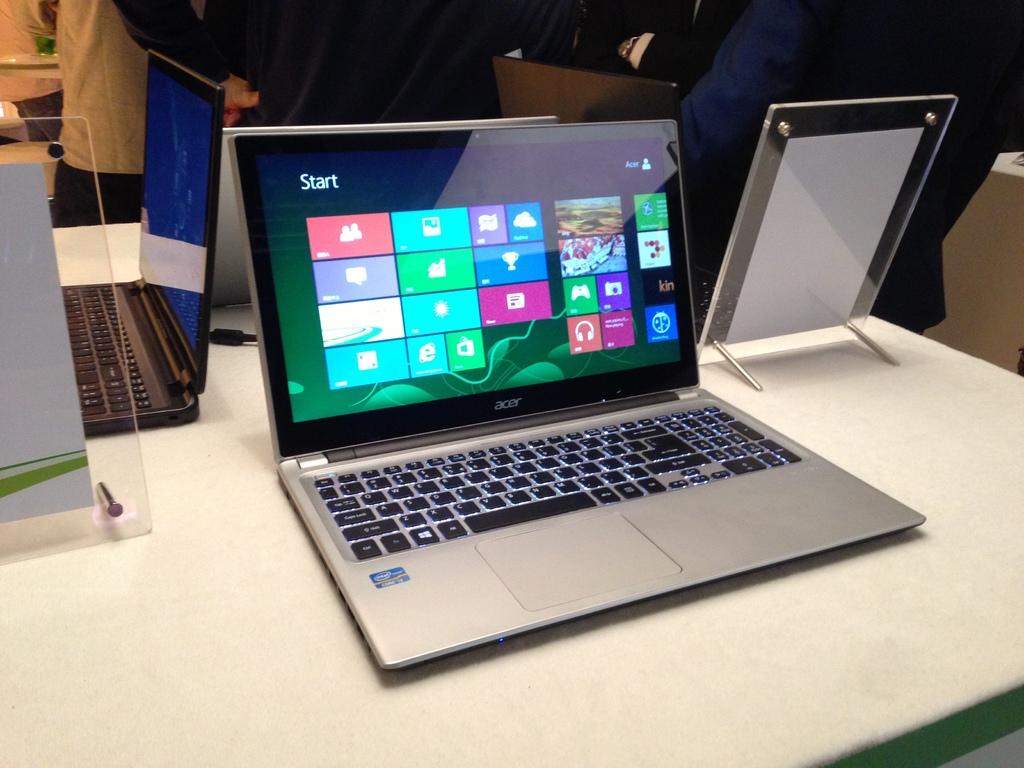<image>
Create a compact narrative representing the image presented. A open chrome laptop that is by the brand Acer. 